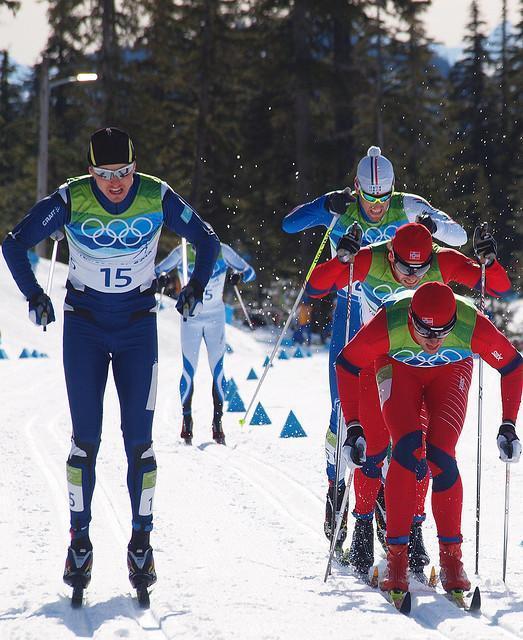How many people can be seen?
Give a very brief answer. 5. How many zebras are there?
Give a very brief answer. 0. 